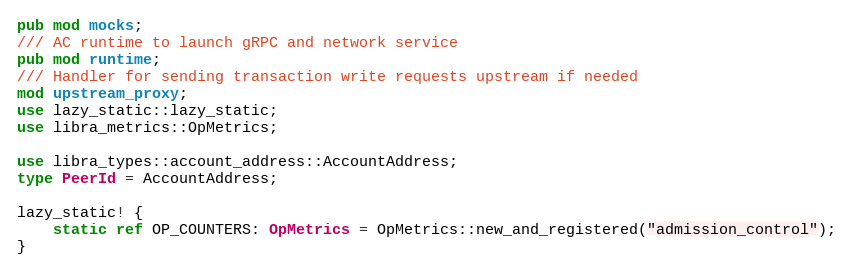<code> <loc_0><loc_0><loc_500><loc_500><_Rust_>pub mod mocks;
/// AC runtime to launch gRPC and network service
pub mod runtime;
/// Handler for sending transaction write requests upstream if needed
mod upstream_proxy;
use lazy_static::lazy_static;
use libra_metrics::OpMetrics;

use libra_types::account_address::AccountAddress;
type PeerId = AccountAddress;

lazy_static! {
    static ref OP_COUNTERS: OpMetrics = OpMetrics::new_and_registered("admission_control");
}
</code> 